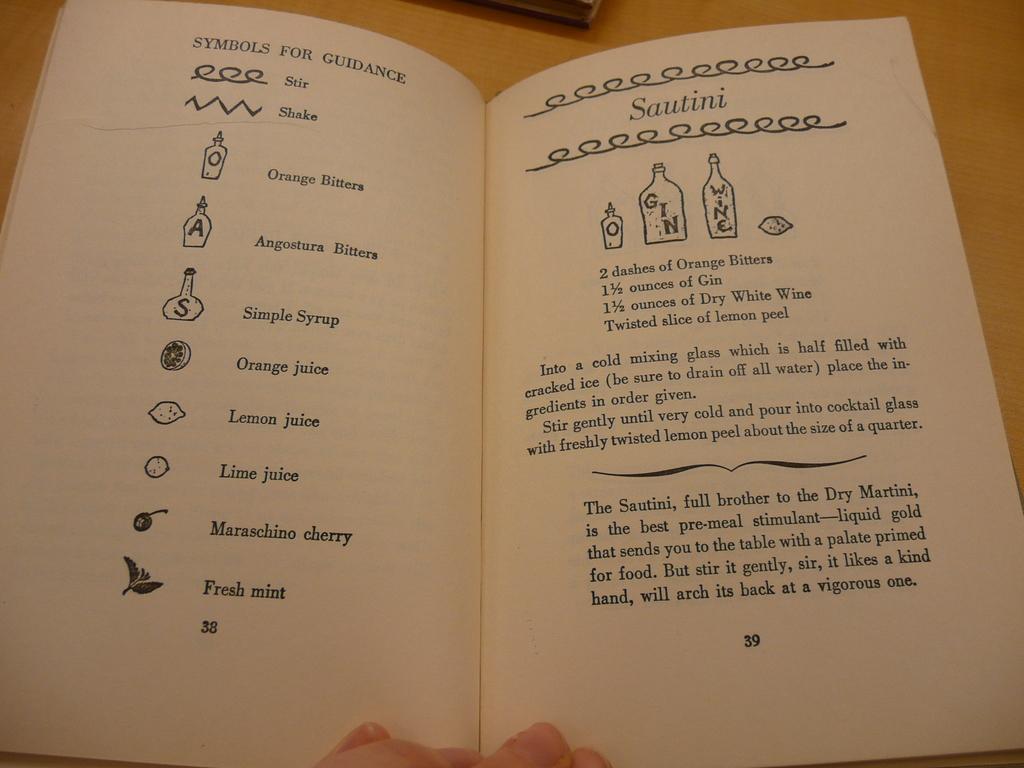What does is the number at the bottom of the page?
Your answer should be compact. 39. 